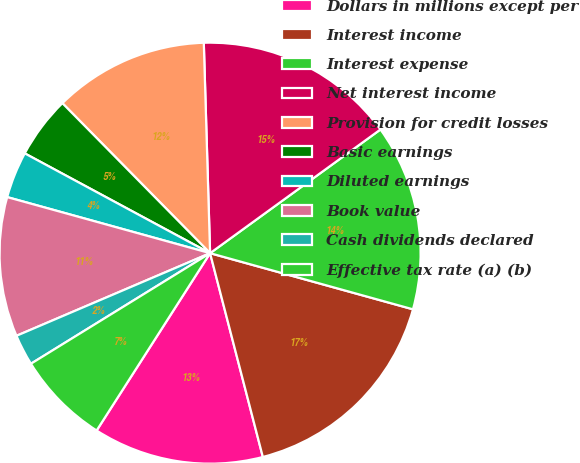Convert chart to OTSL. <chart><loc_0><loc_0><loc_500><loc_500><pie_chart><fcel>Dollars in millions except per<fcel>Interest income<fcel>Interest expense<fcel>Net interest income<fcel>Provision for credit losses<fcel>Basic earnings<fcel>Diluted earnings<fcel>Book value<fcel>Cash dividends declared<fcel>Effective tax rate (a) (b)<nl><fcel>13.09%<fcel>16.67%<fcel>14.29%<fcel>15.48%<fcel>11.9%<fcel>4.76%<fcel>3.57%<fcel>10.71%<fcel>2.38%<fcel>7.14%<nl></chart> 